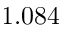<formula> <loc_0><loc_0><loc_500><loc_500>1 . 0 8 4</formula> 